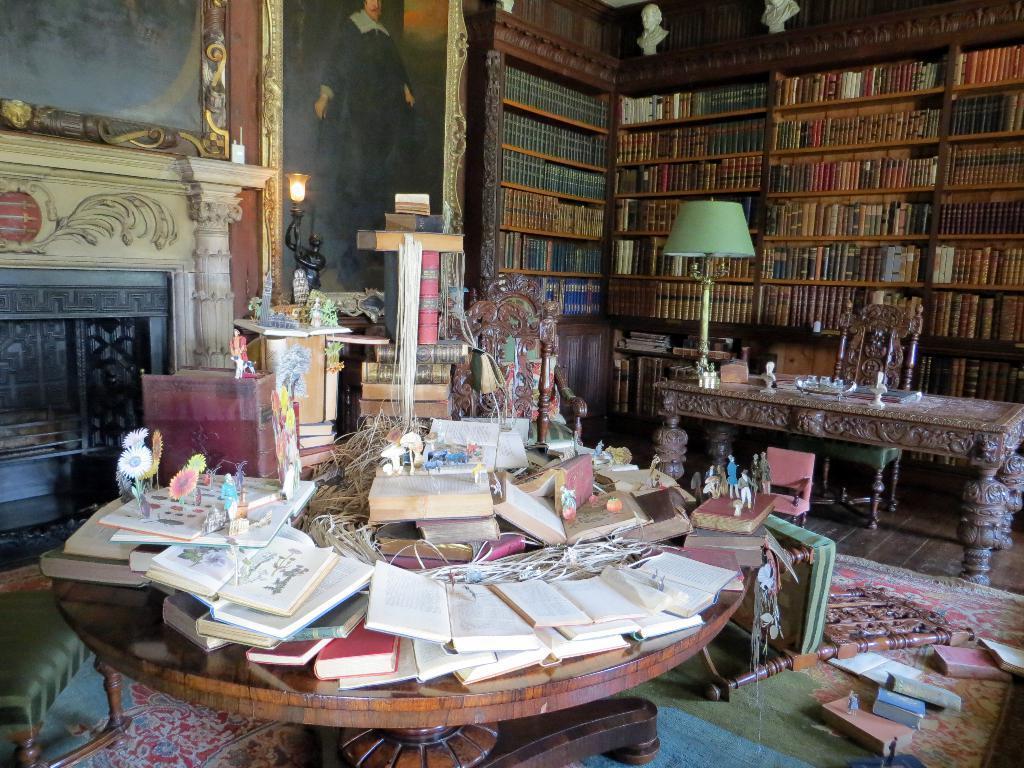In one or two sentences, can you explain what this image depicts? This picture might be taken in a library. In this picture there are many books. In the foreground there is a table, on the table there are many books. On the right there is a table and a chair, on the table there are books and a lamp. In the center background there is a frame. On the left there is a fireplace and a frame. 